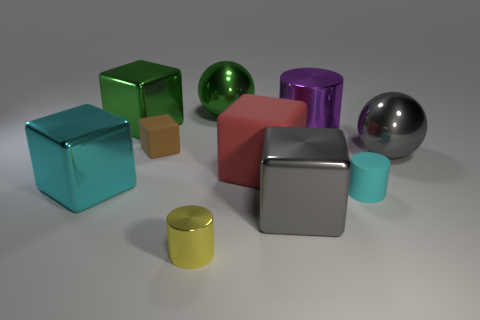How many large blocks have the same color as the rubber cylinder?
Your answer should be very brief. 1. There is a thing that is the same color as the small matte cylinder; what shape is it?
Your answer should be very brief. Cube. How many other objects are the same shape as the big purple object?
Ensure brevity in your answer.  2. How many rubber things are green spheres or big red things?
Provide a short and direct response. 1. There is a big block that is on the left side of the cube that is behind the large cylinder; what is it made of?
Make the answer very short. Metal. Are there more big green objects on the left side of the small block than yellow rubber cubes?
Ensure brevity in your answer.  Yes. Is there a large gray ball made of the same material as the gray cube?
Offer a very short reply. Yes. Is the shape of the tiny thing on the right side of the large cylinder the same as  the tiny brown matte object?
Offer a very short reply. No. How many gray shiny objects are behind the gray object that is behind the cyan thing to the left of the large purple metallic cylinder?
Provide a succinct answer. 0. Is the number of large gray metal spheres behind the big gray cube less than the number of big objects that are in front of the large green cube?
Provide a succinct answer. Yes. 